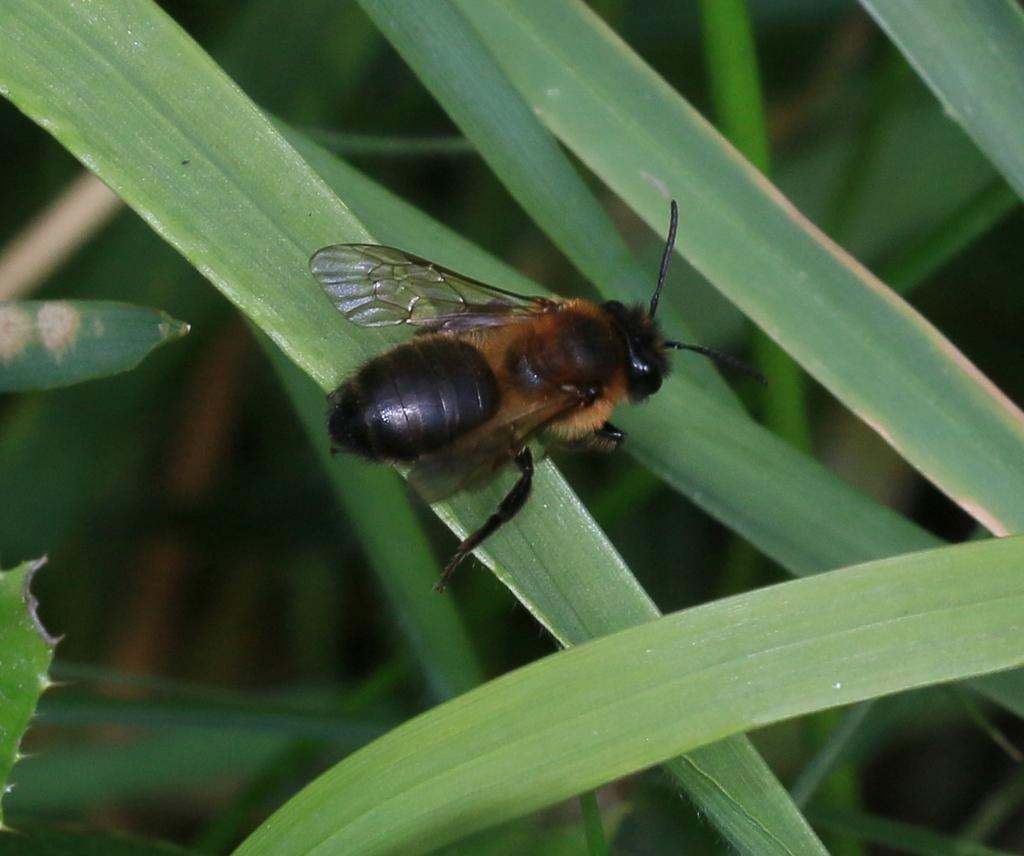What is the main subject in the center of the image? There is an insect in the center of the image. What can be seen in the background of the image? There are leaves in the background of the image. What type of comb is being used by the insect in the image? There is no comb present in the image, as it features an insect and leaves. Can you describe the face of the insect in the image? Insects do not have faces like humans or other mammals, so it is not possible to describe a face in the image. 